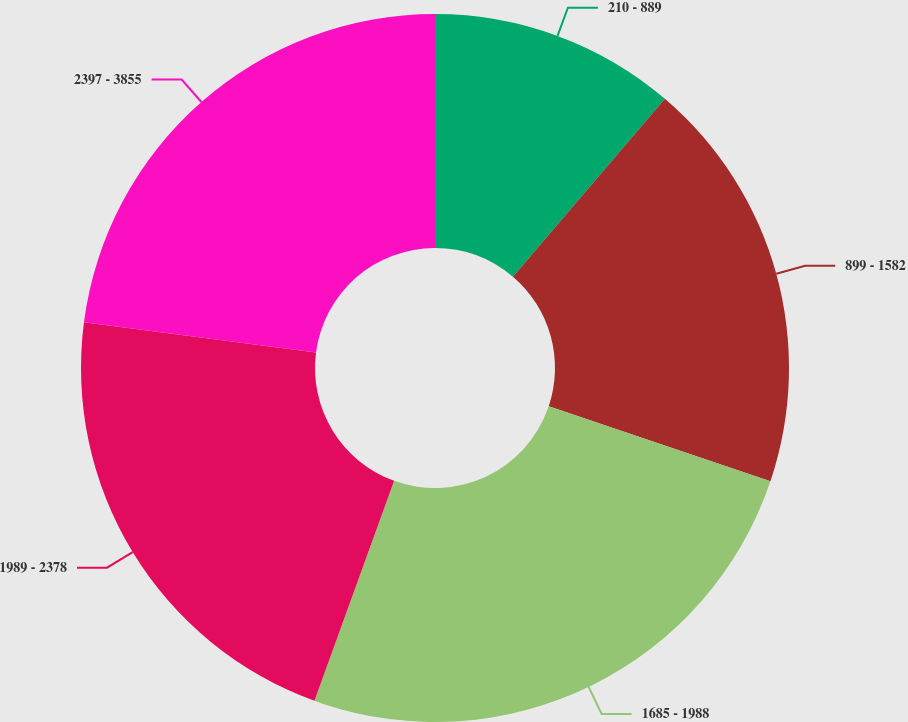<chart> <loc_0><loc_0><loc_500><loc_500><pie_chart><fcel>210 - 889<fcel>899 - 1582<fcel>1685 - 1988<fcel>1989 - 2378<fcel>2397 - 3855<nl><fcel>11.25%<fcel>18.93%<fcel>25.35%<fcel>21.53%<fcel>22.94%<nl></chart> 